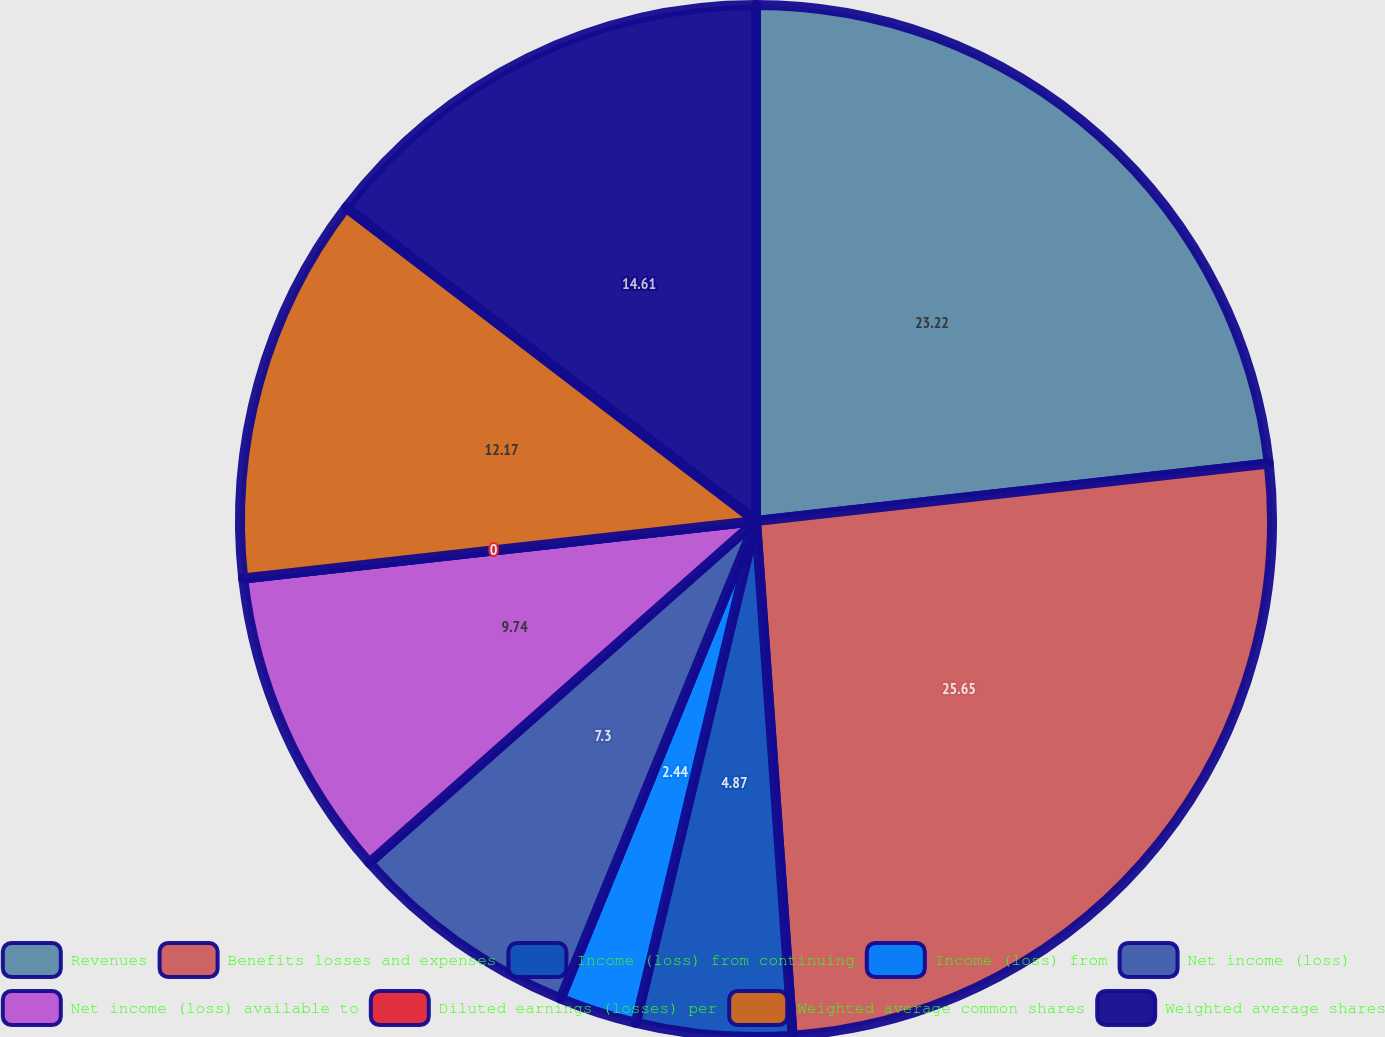Convert chart to OTSL. <chart><loc_0><loc_0><loc_500><loc_500><pie_chart><fcel>Revenues<fcel>Benefits losses and expenses<fcel>Income (loss) from continuing<fcel>Income (loss) from<fcel>Net income (loss)<fcel>Net income (loss) available to<fcel>Diluted earnings (losses) per<fcel>Weighted average common shares<fcel>Weighted average shares<nl><fcel>23.22%<fcel>25.65%<fcel>4.87%<fcel>2.44%<fcel>7.3%<fcel>9.74%<fcel>0.0%<fcel>12.17%<fcel>14.61%<nl></chart> 